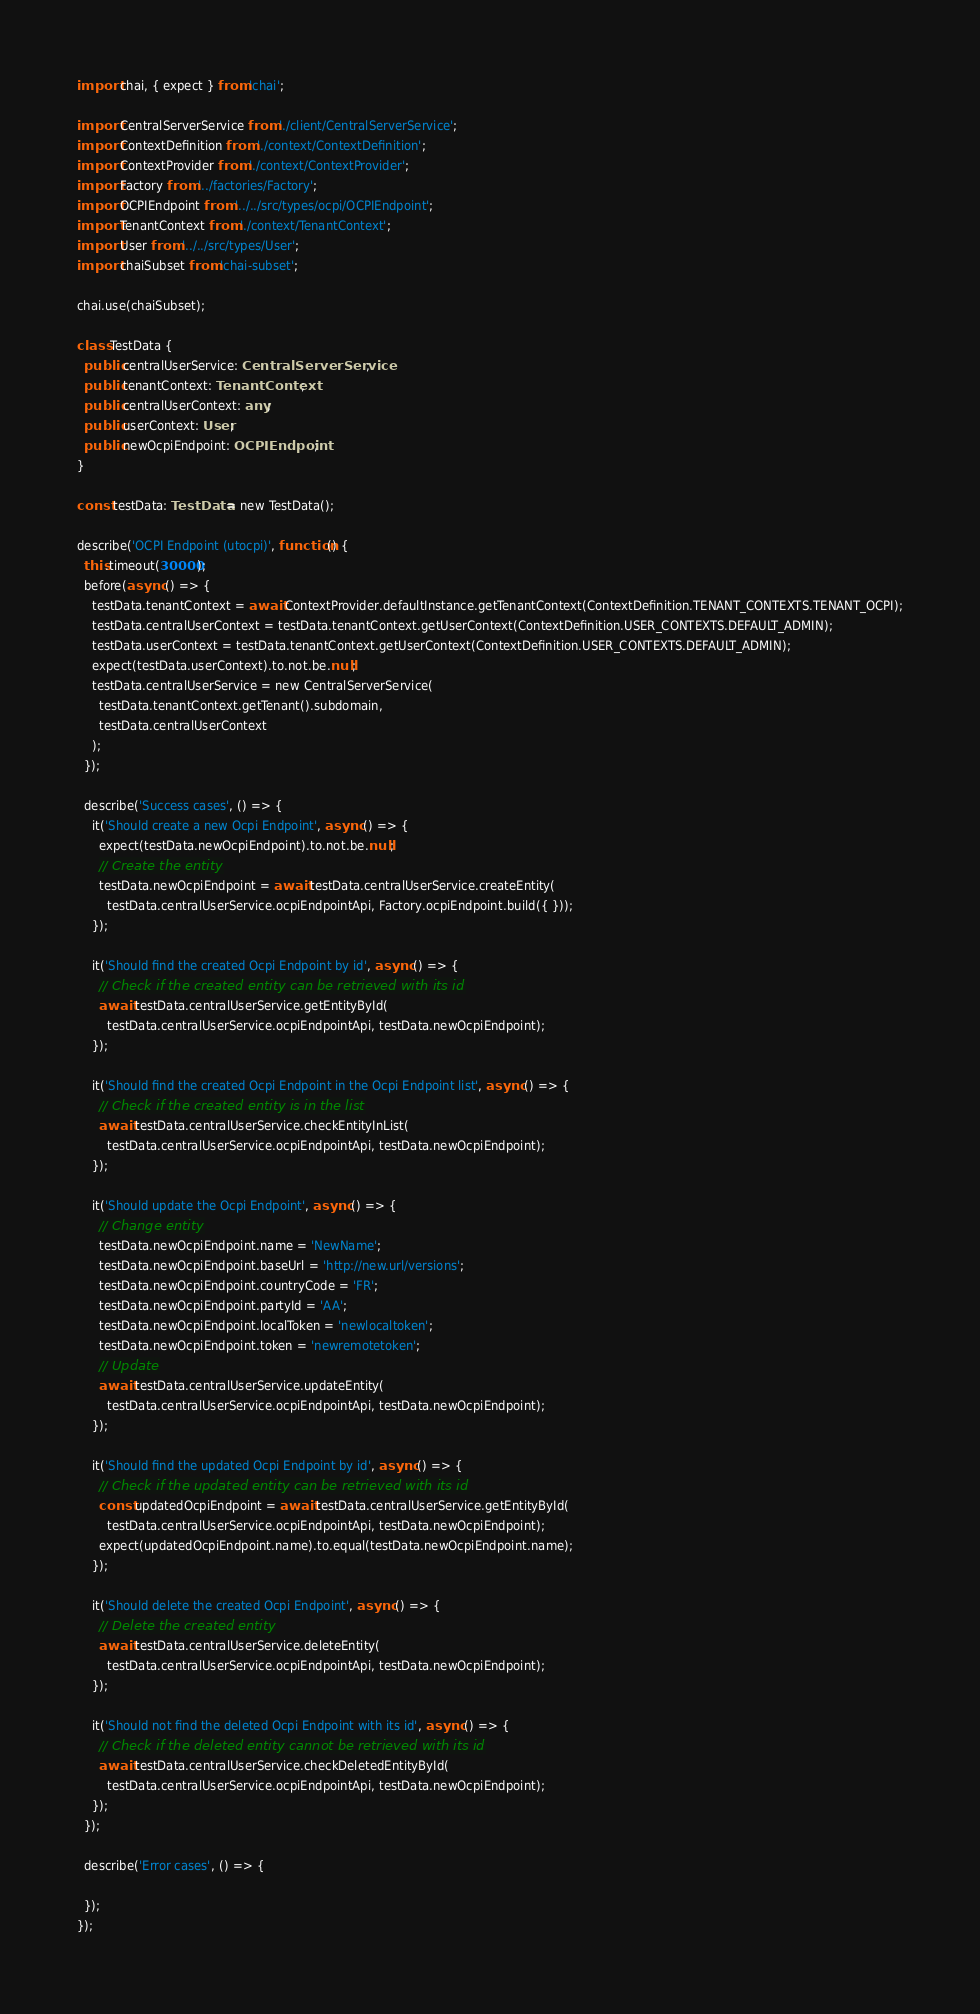<code> <loc_0><loc_0><loc_500><loc_500><_TypeScript_>import chai, { expect } from 'chai';

import CentralServerService from './client/CentralServerService';
import ContextDefinition from './context/ContextDefinition';
import ContextProvider from './context/ContextProvider';
import Factory from '../factories/Factory';
import OCPIEndpoint from '../../src/types/ocpi/OCPIEndpoint';
import TenantContext from './context/TenantContext';
import User from '../../src/types/User';
import chaiSubset from 'chai-subset';

chai.use(chaiSubset);

class TestData {
  public centralUserService: CentralServerService;
  public tenantContext: TenantContext;
  public centralUserContext: any;
  public userContext: User;
  public newOcpiEndpoint: OCPIEndpoint;
}

const testData: TestData = new TestData();

describe('OCPI Endpoint (utocpi)', function() {
  this.timeout(30000);
  before(async () => {
    testData.tenantContext = await ContextProvider.defaultInstance.getTenantContext(ContextDefinition.TENANT_CONTEXTS.TENANT_OCPI);
    testData.centralUserContext = testData.tenantContext.getUserContext(ContextDefinition.USER_CONTEXTS.DEFAULT_ADMIN);
    testData.userContext = testData.tenantContext.getUserContext(ContextDefinition.USER_CONTEXTS.DEFAULT_ADMIN);
    expect(testData.userContext).to.not.be.null;
    testData.centralUserService = new CentralServerService(
      testData.tenantContext.getTenant().subdomain,
      testData.centralUserContext
    );
  });

  describe('Success cases', () => {
    it('Should create a new Ocpi Endpoint', async () => {
      expect(testData.newOcpiEndpoint).to.not.be.null;
      // Create the entity
      testData.newOcpiEndpoint = await testData.centralUserService.createEntity(
        testData.centralUserService.ocpiEndpointApi, Factory.ocpiEndpoint.build({ }));
    });

    it('Should find the created Ocpi Endpoint by id', async () => {
      // Check if the created entity can be retrieved with its id
      await testData.centralUserService.getEntityById(
        testData.centralUserService.ocpiEndpointApi, testData.newOcpiEndpoint);
    });

    it('Should find the created Ocpi Endpoint in the Ocpi Endpoint list', async () => {
      // Check if the created entity is in the list
      await testData.centralUserService.checkEntityInList(
        testData.centralUserService.ocpiEndpointApi, testData.newOcpiEndpoint);
    });

    it('Should update the Ocpi Endpoint', async () => {
      // Change entity
      testData.newOcpiEndpoint.name = 'NewName';
      testData.newOcpiEndpoint.baseUrl = 'http://new.url/versions';
      testData.newOcpiEndpoint.countryCode = 'FR';
      testData.newOcpiEndpoint.partyId = 'AA';
      testData.newOcpiEndpoint.localToken = 'newlocaltoken';
      testData.newOcpiEndpoint.token = 'newremotetoken';
      // Update
      await testData.centralUserService.updateEntity(
        testData.centralUserService.ocpiEndpointApi, testData.newOcpiEndpoint);
    });

    it('Should find the updated Ocpi Endpoint by id', async () => {
      // Check if the updated entity can be retrieved with its id
      const updatedOcpiEndpoint = await testData.centralUserService.getEntityById(
        testData.centralUserService.ocpiEndpointApi, testData.newOcpiEndpoint);
      expect(updatedOcpiEndpoint.name).to.equal(testData.newOcpiEndpoint.name);
    });

    it('Should delete the created Ocpi Endpoint', async () => {
      // Delete the created entity
      await testData.centralUserService.deleteEntity(
        testData.centralUserService.ocpiEndpointApi, testData.newOcpiEndpoint);
    });

    it('Should not find the deleted Ocpi Endpoint with its id', async () => {
      // Check if the deleted entity cannot be retrieved with its id
      await testData.centralUserService.checkDeletedEntityById(
        testData.centralUserService.ocpiEndpointApi, testData.newOcpiEndpoint);
    });
  });

  describe('Error cases', () => {

  });
});
</code> 